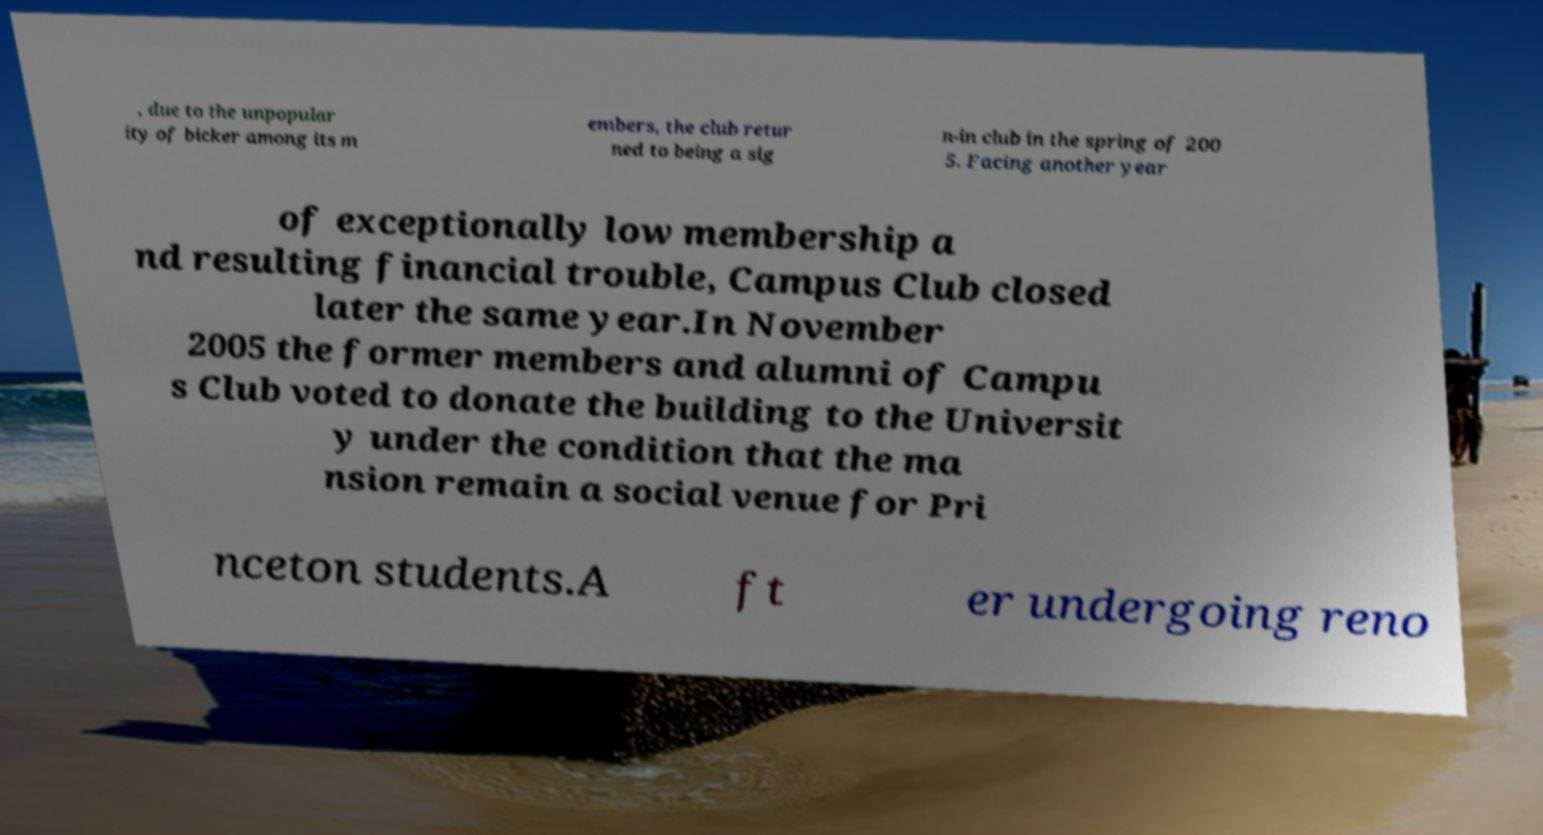Can you read and provide the text displayed in the image?This photo seems to have some interesting text. Can you extract and type it out for me? , due to the unpopular ity of bicker among its m embers, the club retur ned to being a sig n-in club in the spring of 200 5. Facing another year of exceptionally low membership a nd resulting financial trouble, Campus Club closed later the same year.In November 2005 the former members and alumni of Campu s Club voted to donate the building to the Universit y under the condition that the ma nsion remain a social venue for Pri nceton students.A ft er undergoing reno 